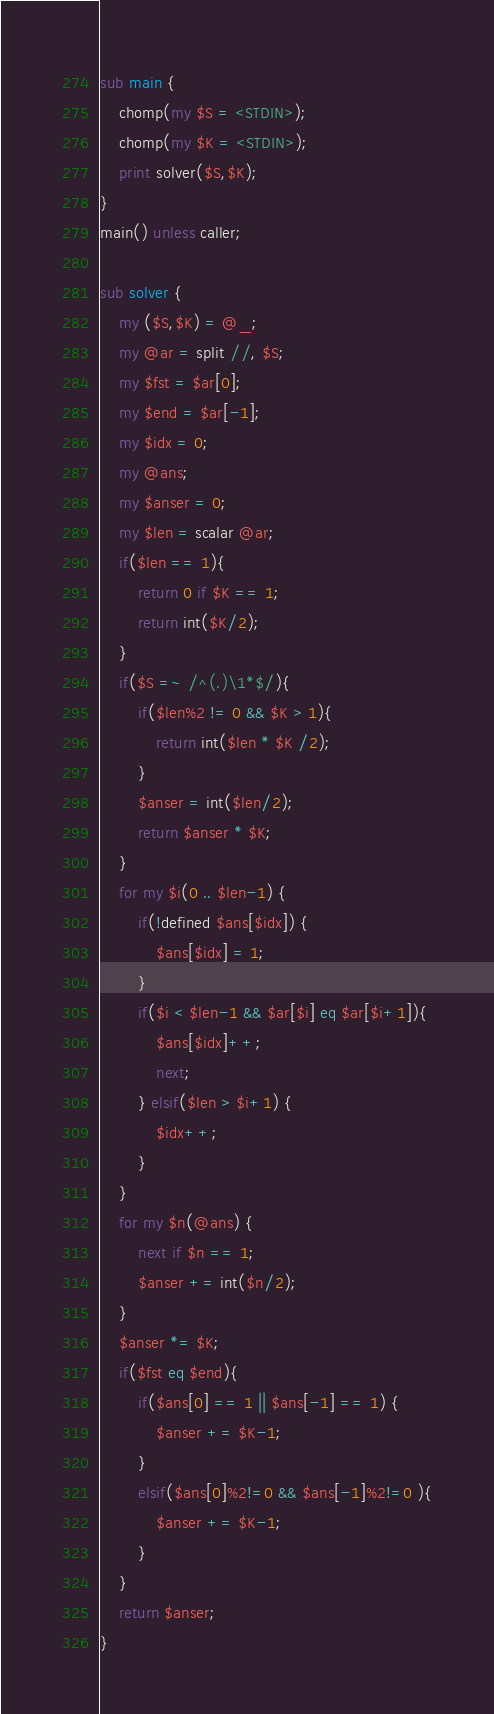<code> <loc_0><loc_0><loc_500><loc_500><_Perl_>sub main {
    chomp(my $S = <STDIN>);
    chomp(my $K = <STDIN>);
    print solver($S,$K);
}
main() unless caller;

sub solver {
    my ($S,$K) = @_;
    my @ar = split //, $S;
    my $fst = $ar[0];
    my $end = $ar[-1];
    my $idx = 0;
    my @ans;
    my $anser = 0;
    my $len = scalar @ar;
    if($len == 1){
        return 0 if $K == 1;
        return int($K/2);
    }
    if($S =~ /^(.)\1*$/){
        if($len%2 != 0 && $K > 1){
            return int($len * $K /2);
        }
        $anser = int($len/2);
        return $anser * $K;
    }
    for my $i(0 .. $len-1) {
        if(!defined $ans[$idx]) {
            $ans[$idx] = 1;
        }
        if($i < $len-1 && $ar[$i] eq $ar[$i+1]){
            $ans[$idx]++;
            next;
        } elsif($len > $i+1) {
            $idx++;
        }
    }
    for my $n(@ans) {
        next if $n == 1;
        $anser += int($n/2);
    }
    $anser *= $K;
    if($fst eq $end){
        if($ans[0] == 1 || $ans[-1] == 1) {
            $anser += $K-1;
        }
        elsif($ans[0]%2!=0 && $ans[-1]%2!=0 ){
            $anser += $K-1;
        }
    }
    return $anser;
}</code> 